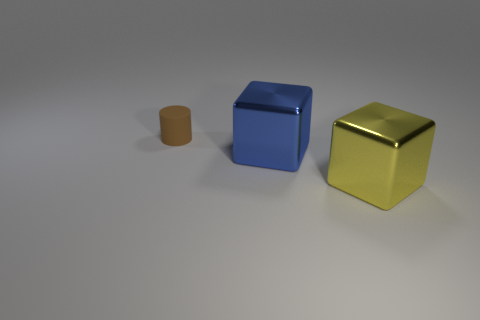Add 3 tiny green rubber cylinders. How many objects exist? 6 Subtract all cylinders. How many objects are left? 2 Subtract 0 purple spheres. How many objects are left? 3 Subtract all tiny red rubber balls. Subtract all cubes. How many objects are left? 1 Add 3 large metal blocks. How many large metal blocks are left? 5 Add 2 blue things. How many blue things exist? 3 